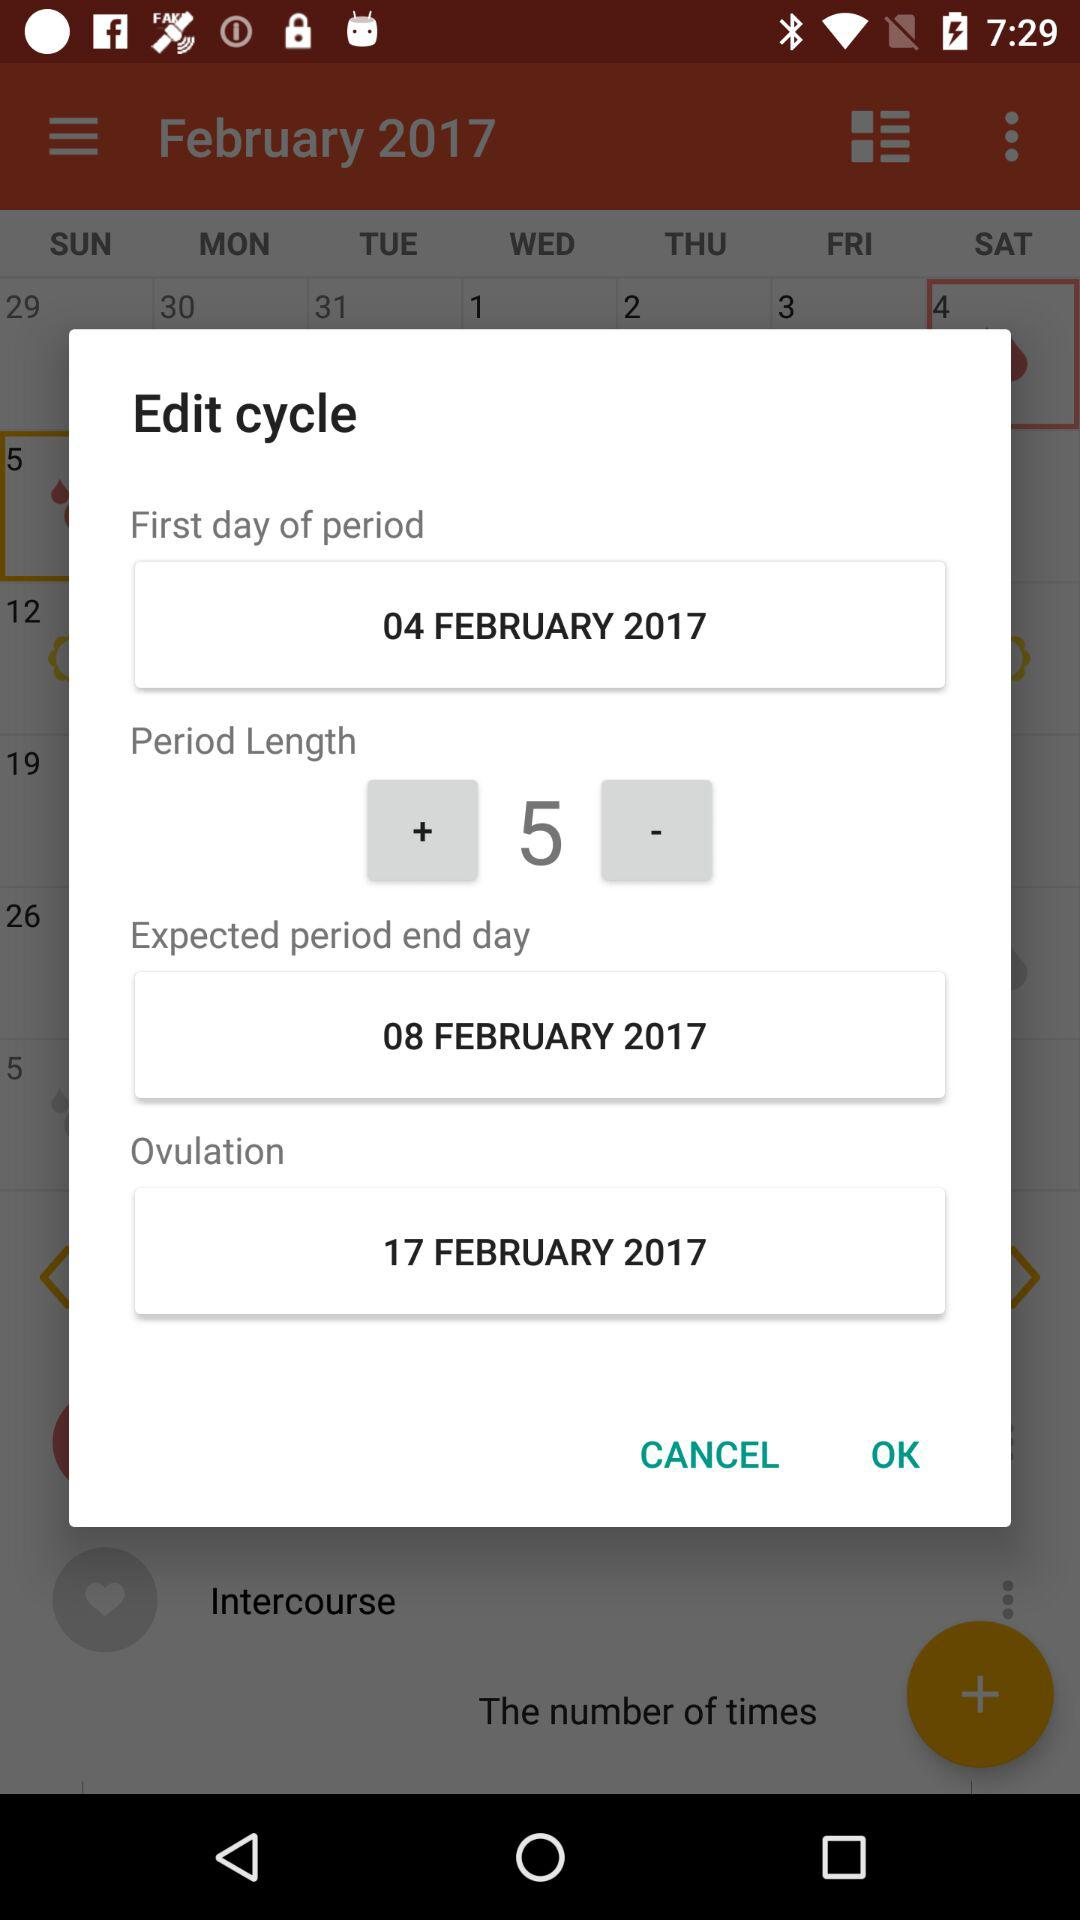What is the expected period end date? The expected period end date is February 8, 2017. 